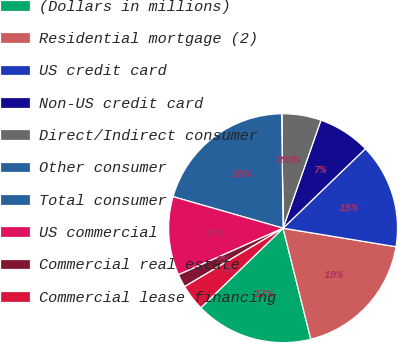<chart> <loc_0><loc_0><loc_500><loc_500><pie_chart><fcel>(Dollars in millions)<fcel>Residential mortgage (2)<fcel>US credit card<fcel>Non-US credit card<fcel>Direct/Indirect consumer<fcel>Other consumer<fcel>Total consumer<fcel>US commercial<fcel>Commercial real estate<fcel>Commercial lease financing<nl><fcel>16.66%<fcel>18.51%<fcel>14.81%<fcel>7.41%<fcel>5.56%<fcel>0.01%<fcel>20.36%<fcel>11.11%<fcel>1.86%<fcel>3.71%<nl></chart> 